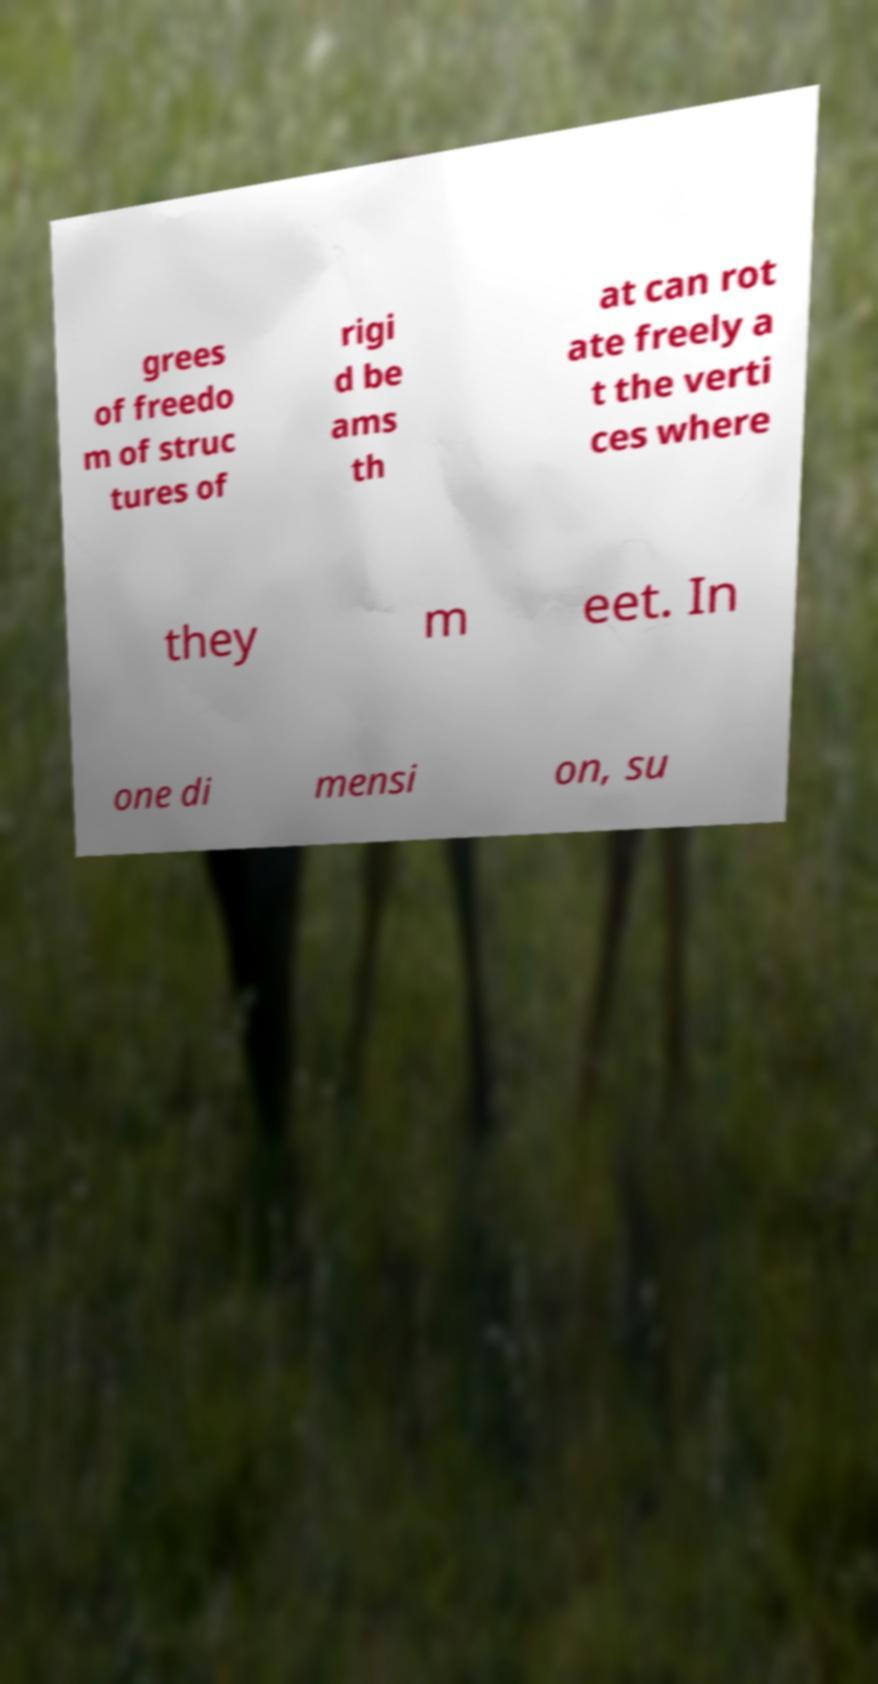For documentation purposes, I need the text within this image transcribed. Could you provide that? grees of freedo m of struc tures of rigi d be ams th at can rot ate freely a t the verti ces where they m eet. In one di mensi on, su 